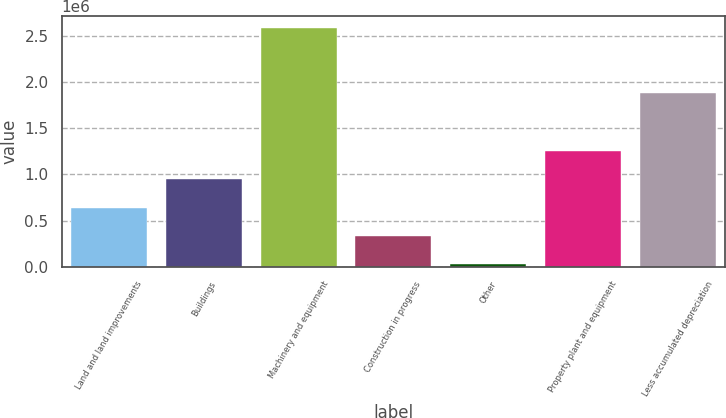<chart> <loc_0><loc_0><loc_500><loc_500><bar_chart><fcel>Land and land improvements<fcel>Buildings<fcel>Machinery and equipment<fcel>Construction in progress<fcel>Other<fcel>Property plant and equipment<fcel>Less accumulated depreciation<nl><fcel>641134<fcel>948471<fcel>2.589e+06<fcel>333796<fcel>26459<fcel>1.25581e+06<fcel>1.87881e+06<nl></chart> 